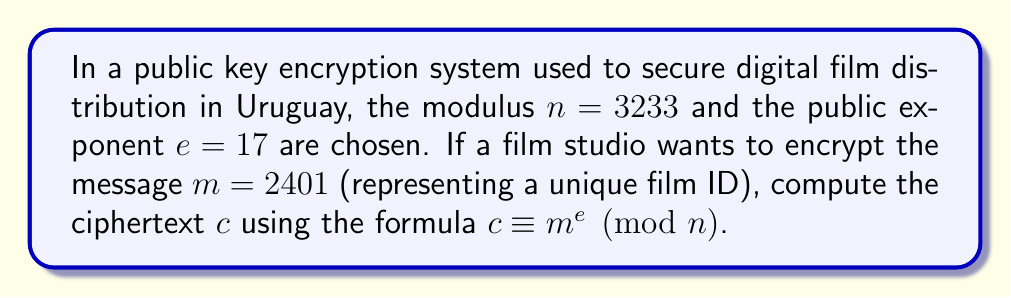Help me with this question. To compute the modular exponentiation, we need to calculate $2401^{17} \pmod{3233}$. This can be done efficiently using the square-and-multiply algorithm:

1) First, convert the exponent (17) to binary: $17_{10} = 10001_2$

2) Initialize: $result = 1$, $base = 2401$

3) For each bit in the binary exponent (from left to right):
   a) Square the result: $result = result^2 \pmod{3233}$
   b) If the bit is 1, multiply by the base: $result = result \times base \pmod{3233}$

Step-by-step calculation:

$$\begin{align*}
1: & \quad result = 1^2 \times 2401 = 2401 \pmod{3233} \\
0: & \quad result = 2401^2 = 2280 \pmod{3233} \\
0: & \quad result = 2280^2 = 1298 \pmod{3233} \\
0: & \quad result = 1298^2 = 756 \pmod{3233} \\
1: & \quad result = 756^2 \times 2401 = 2964 \pmod{3233}
\end{align*}$$

Therefore, the ciphertext $c = 2964$.
Answer: $2964$ 